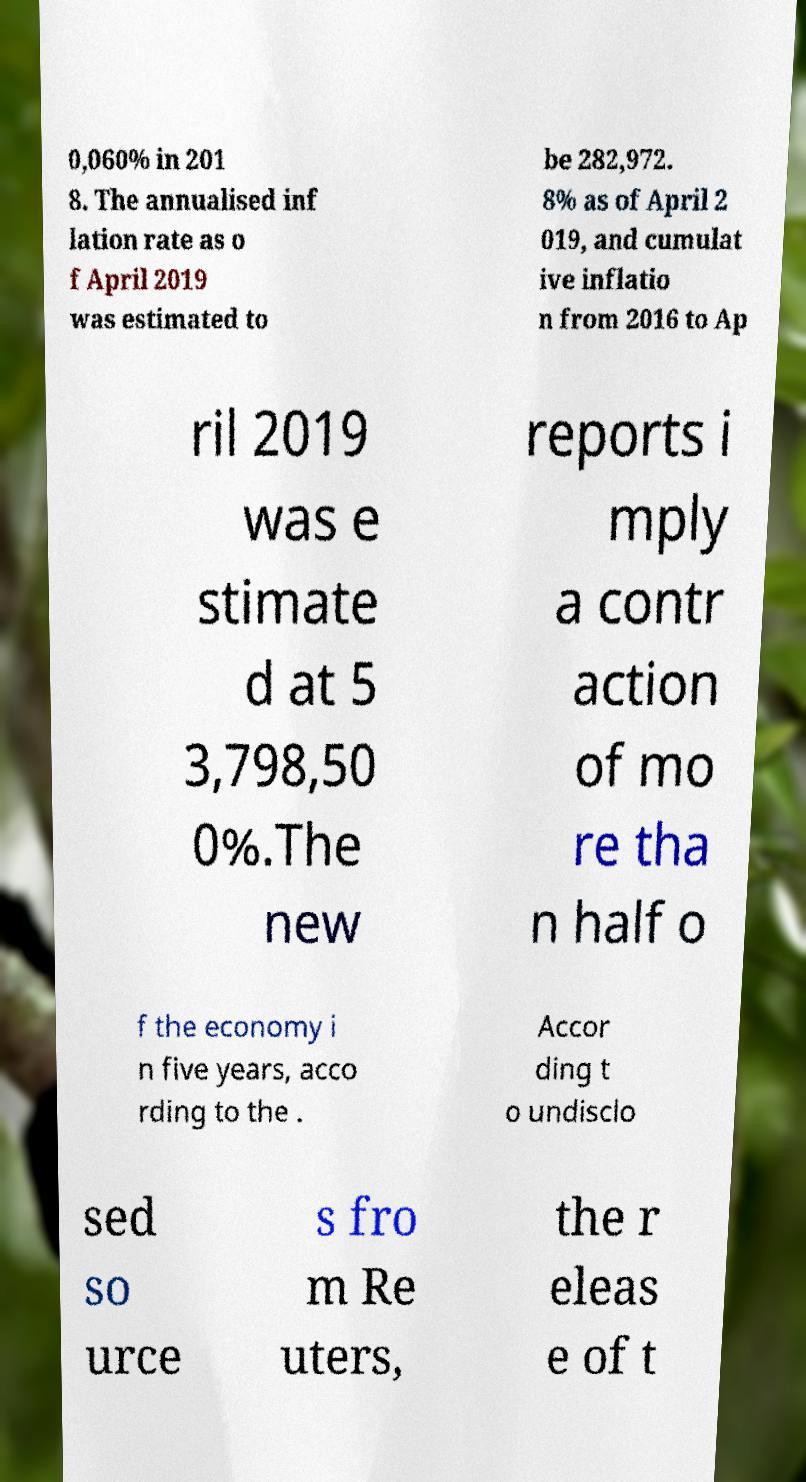There's text embedded in this image that I need extracted. Can you transcribe it verbatim? 0,060% in 201 8. The annualised inf lation rate as o f April 2019 was estimated to be 282,972. 8% as of April 2 019, and cumulat ive inflatio n from 2016 to Ap ril 2019 was e stimate d at 5 3,798,50 0%.The new reports i mply a contr action of mo re tha n half o f the economy i n five years, acco rding to the . Accor ding t o undisclo sed so urce s fro m Re uters, the r eleas e of t 